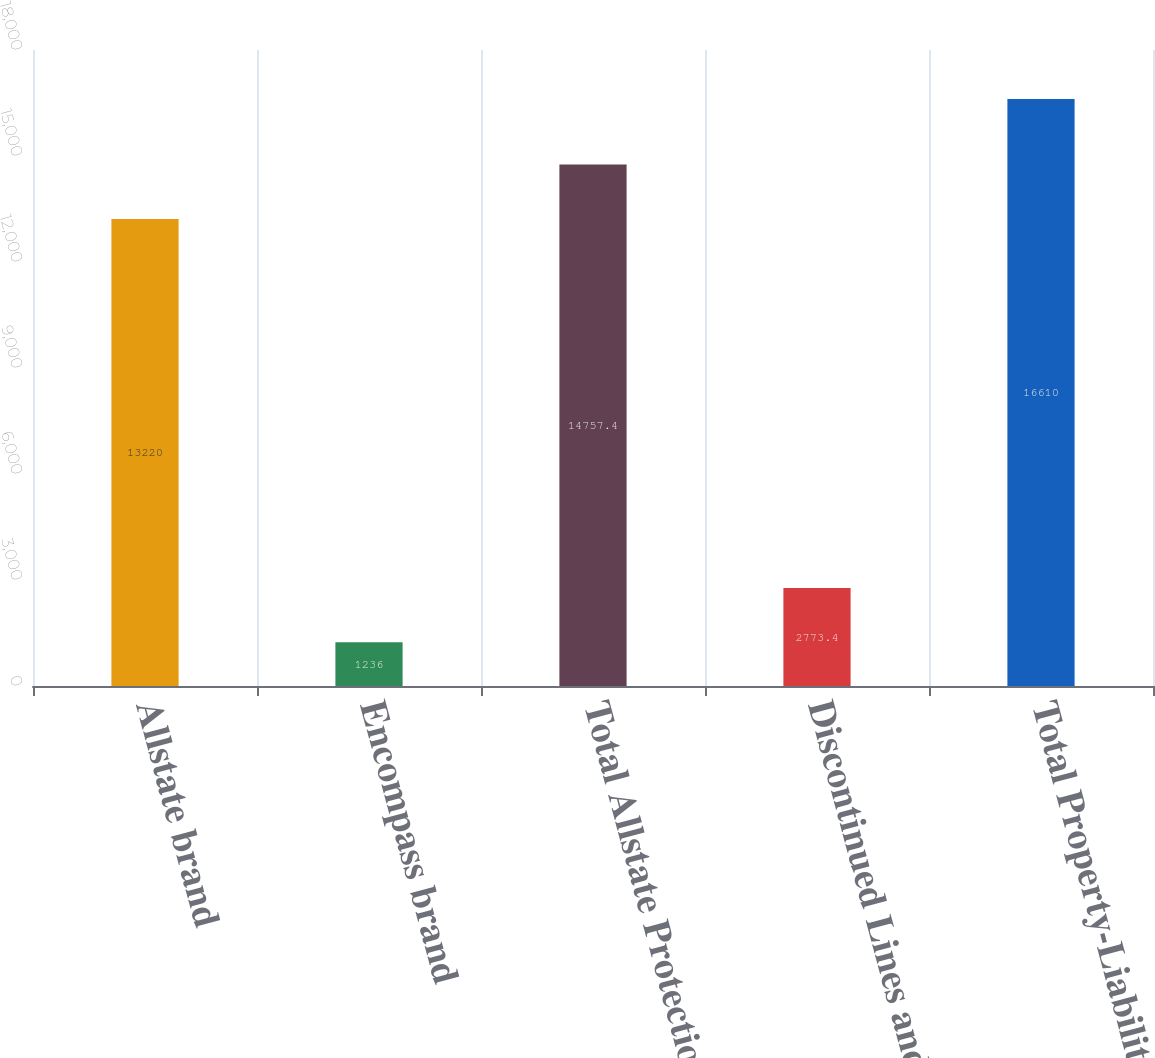<chart> <loc_0><loc_0><loc_500><loc_500><bar_chart><fcel>Allstate brand<fcel>Encompass brand<fcel>Total Allstate Protection<fcel>Discontinued Lines and<fcel>Total Property-Liability<nl><fcel>13220<fcel>1236<fcel>14757.4<fcel>2773.4<fcel>16610<nl></chart> 